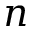Convert formula to latex. <formula><loc_0><loc_0><loc_500><loc_500>n</formula> 